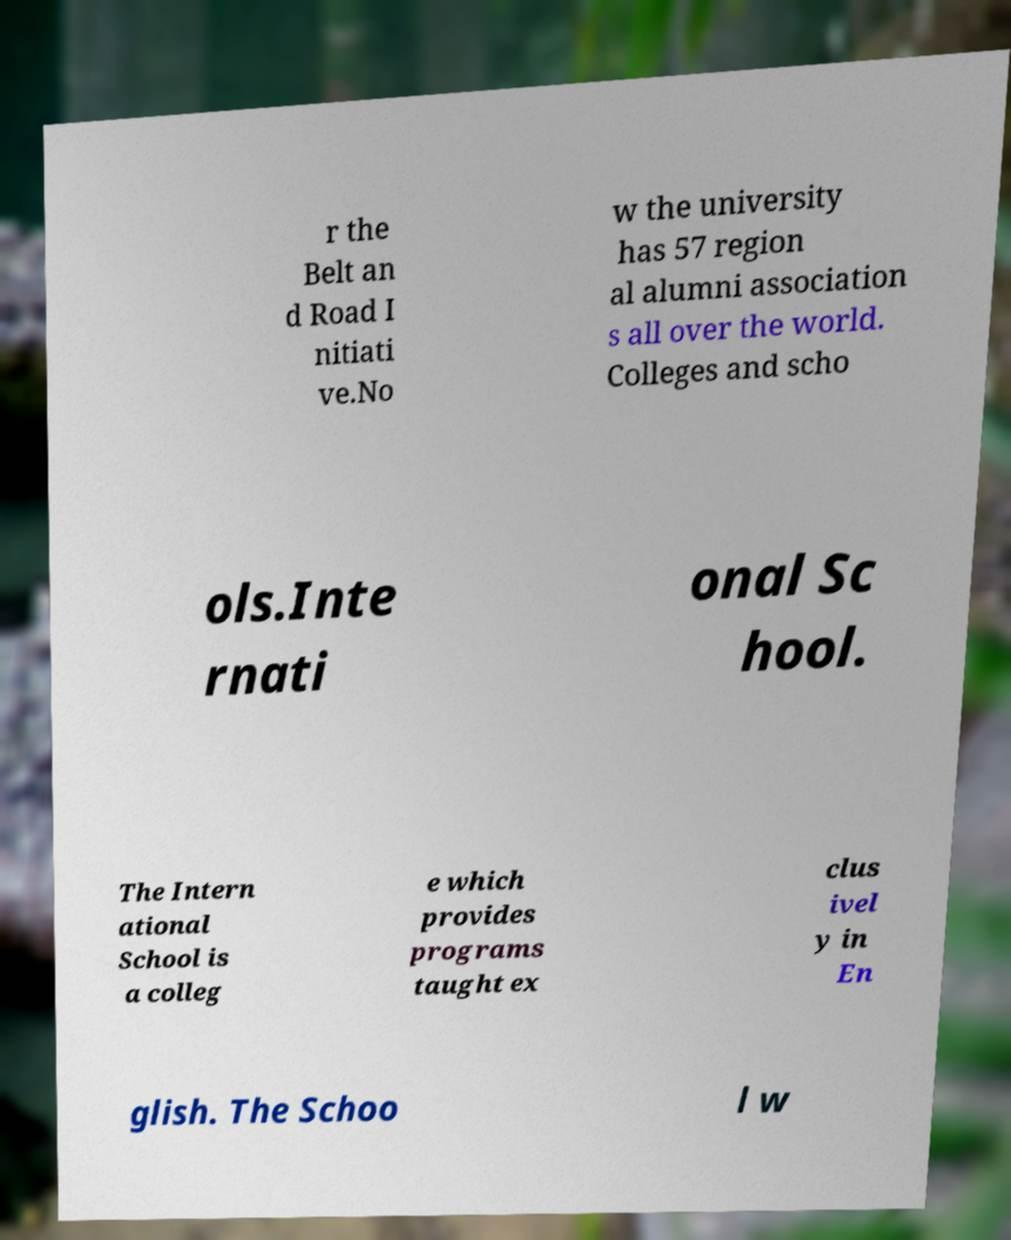I need the written content from this picture converted into text. Can you do that? r the Belt an d Road I nitiati ve.No w the university has 57 region al alumni association s all over the world. Colleges and scho ols.Inte rnati onal Sc hool. The Intern ational School is a colleg e which provides programs taught ex clus ivel y in En glish. The Schoo l w 